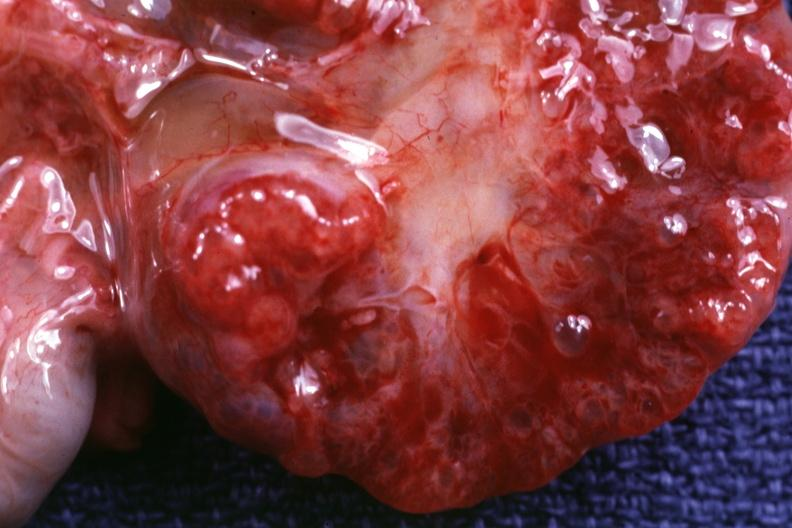does linear fracture in occiput show close-up of cut surface?
Answer the question using a single word or phrase. No 